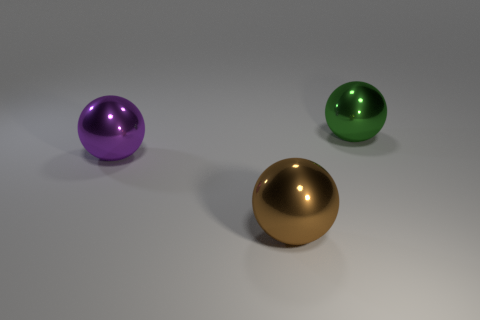Add 2 big objects. How many objects exist? 5 Subtract 0 red blocks. How many objects are left? 3 Subtract all large gray rubber cylinders. Subtract all large metal spheres. How many objects are left? 0 Add 1 purple metal objects. How many purple metal objects are left? 2 Add 2 purple spheres. How many purple spheres exist? 3 